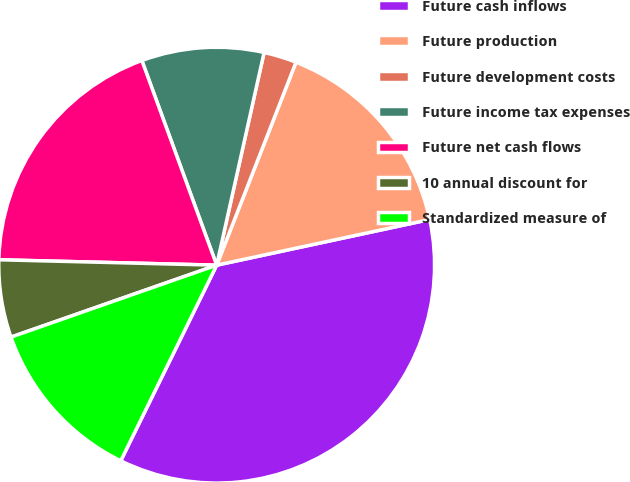Convert chart. <chart><loc_0><loc_0><loc_500><loc_500><pie_chart><fcel>Future cash inflows<fcel>Future production<fcel>Future development costs<fcel>Future income tax expenses<fcel>Future net cash flows<fcel>10 annual discount for<fcel>Standardized measure of<nl><fcel>35.62%<fcel>15.71%<fcel>2.44%<fcel>9.07%<fcel>19.03%<fcel>5.75%<fcel>12.39%<nl></chart> 